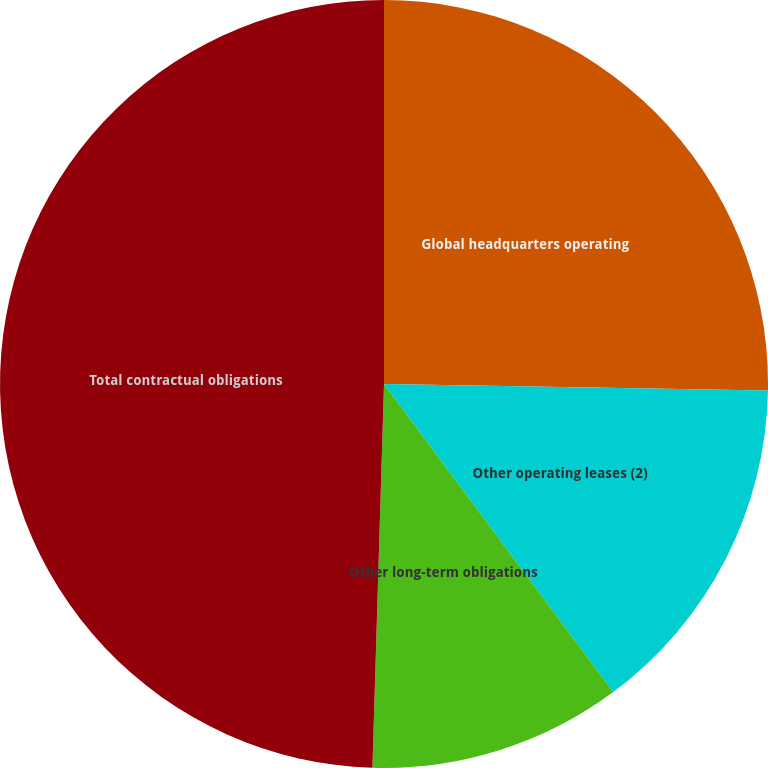Convert chart. <chart><loc_0><loc_0><loc_500><loc_500><pie_chart><fcel>Global headquarters operating<fcel>Other operating leases (2)<fcel>Other long-term obligations<fcel>Total contractual obligations<nl><fcel>25.27%<fcel>14.55%<fcel>10.66%<fcel>49.52%<nl></chart> 